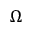Convert formula to latex. <formula><loc_0><loc_0><loc_500><loc_500>\Omega</formula> 